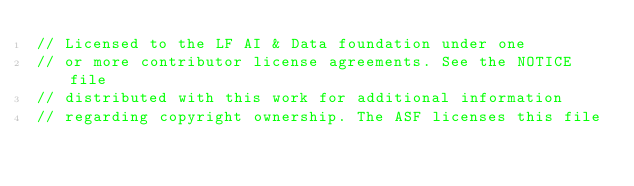<code> <loc_0><loc_0><loc_500><loc_500><_Go_>// Licensed to the LF AI & Data foundation under one
// or more contributor license agreements. See the NOTICE file
// distributed with this work for additional information
// regarding copyright ownership. The ASF licenses this file</code> 